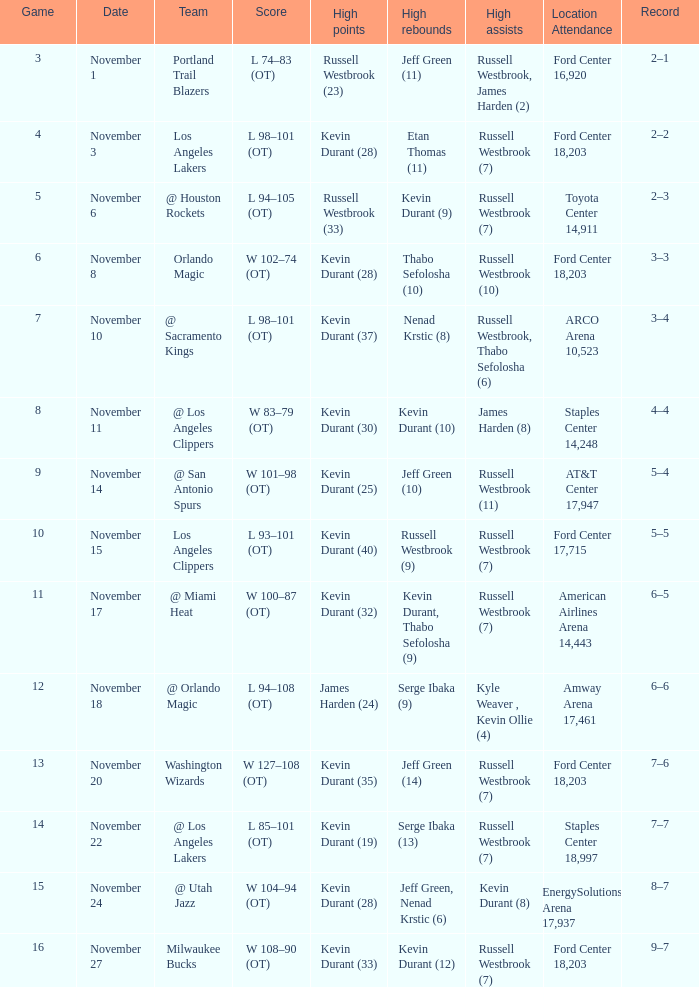Write the full table. {'header': ['Game', 'Date', 'Team', 'Score', 'High points', 'High rebounds', 'High assists', 'Location Attendance', 'Record'], 'rows': [['3', 'November 1', 'Portland Trail Blazers', 'L 74–83 (OT)', 'Russell Westbrook (23)', 'Jeff Green (11)', 'Russell Westbrook, James Harden (2)', 'Ford Center 16,920', '2–1'], ['4', 'November 3', 'Los Angeles Lakers', 'L 98–101 (OT)', 'Kevin Durant (28)', 'Etan Thomas (11)', 'Russell Westbrook (7)', 'Ford Center 18,203', '2–2'], ['5', 'November 6', '@ Houston Rockets', 'L 94–105 (OT)', 'Russell Westbrook (33)', 'Kevin Durant (9)', 'Russell Westbrook (7)', 'Toyota Center 14,911', '2–3'], ['6', 'November 8', 'Orlando Magic', 'W 102–74 (OT)', 'Kevin Durant (28)', 'Thabo Sefolosha (10)', 'Russell Westbrook (10)', 'Ford Center 18,203', '3–3'], ['7', 'November 10', '@ Sacramento Kings', 'L 98–101 (OT)', 'Kevin Durant (37)', 'Nenad Krstic (8)', 'Russell Westbrook, Thabo Sefolosha (6)', 'ARCO Arena 10,523', '3–4'], ['8', 'November 11', '@ Los Angeles Clippers', 'W 83–79 (OT)', 'Kevin Durant (30)', 'Kevin Durant (10)', 'James Harden (8)', 'Staples Center 14,248', '4–4'], ['9', 'November 14', '@ San Antonio Spurs', 'W 101–98 (OT)', 'Kevin Durant (25)', 'Jeff Green (10)', 'Russell Westbrook (11)', 'AT&T Center 17,947', '5–4'], ['10', 'November 15', 'Los Angeles Clippers', 'L 93–101 (OT)', 'Kevin Durant (40)', 'Russell Westbrook (9)', 'Russell Westbrook (7)', 'Ford Center 17,715', '5–5'], ['11', 'November 17', '@ Miami Heat', 'W 100–87 (OT)', 'Kevin Durant (32)', 'Kevin Durant, Thabo Sefolosha (9)', 'Russell Westbrook (7)', 'American Airlines Arena 14,443', '6–5'], ['12', 'November 18', '@ Orlando Magic', 'L 94–108 (OT)', 'James Harden (24)', 'Serge Ibaka (9)', 'Kyle Weaver , Kevin Ollie (4)', 'Amway Arena 17,461', '6–6'], ['13', 'November 20', 'Washington Wizards', 'W 127–108 (OT)', 'Kevin Durant (35)', 'Jeff Green (14)', 'Russell Westbrook (7)', 'Ford Center 18,203', '7–6'], ['14', 'November 22', '@ Los Angeles Lakers', 'L 85–101 (OT)', 'Kevin Durant (19)', 'Serge Ibaka (13)', 'Russell Westbrook (7)', 'Staples Center 18,997', '7–7'], ['15', 'November 24', '@ Utah Jazz', 'W 104–94 (OT)', 'Kevin Durant (28)', 'Jeff Green, Nenad Krstic (6)', 'Kevin Durant (8)', 'EnergySolutions Arena 17,937', '8–7'], ['16', 'November 27', 'Milwaukee Bucks', 'W 108–90 (OT)', 'Kevin Durant (33)', 'Kevin Durant (12)', 'Russell Westbrook (7)', 'Ford Center 18,203', '9–7']]} In which game with the most rebounds by jeff green (14), what was the overall record? 7–6. 